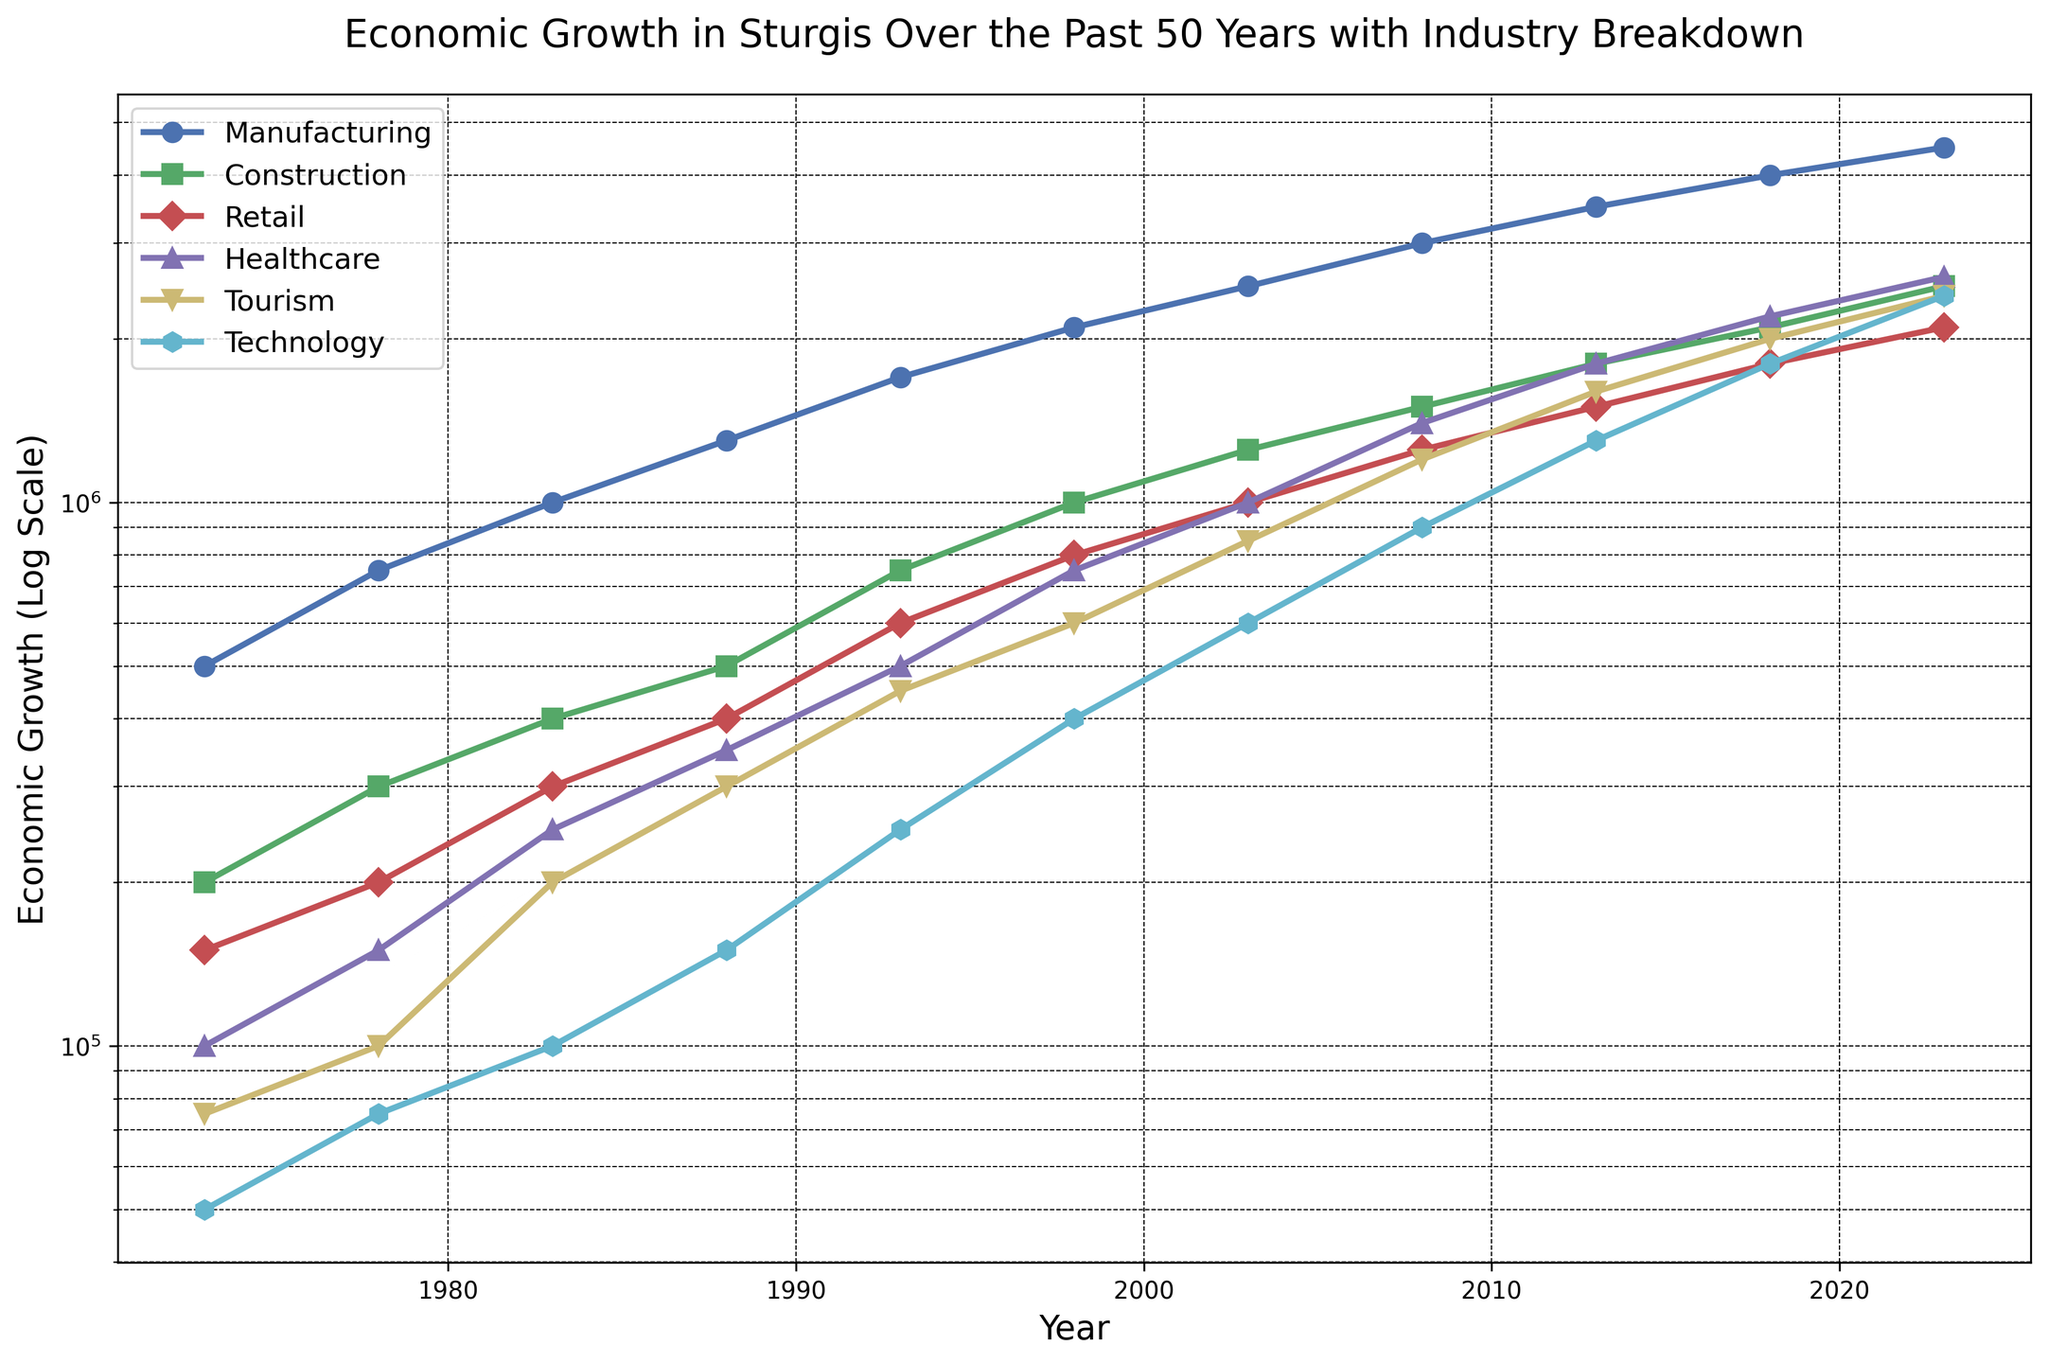Which industry experienced the highest economic growth in 1973? Look at the values for each industry in 1973. Manufacturing has the highest value at $500,000.
Answer: Manufacturing In 2023, how much higher is the economic growth in Healthcare compared to Retail? In 2023, the economic growth for Healthcare is $2,600,000 and for Retail it is $2,100,000. The difference is $2,600,000 - $2,100,000 = $500,000.
Answer: $500,000 By how much did the Technology sector grow between 2003 and 2023? In 2003, Technology had an economic growth of $600,000 and in 2023 it had $2,400,000. The growth is $2,400,000 - $600,000 = $1,800,000.
Answer: $1,800,000 Which two industries had the same economic growth in any given year? In 2013, Healthcare and Tourism both had an economic growth of $1,800,000. This is visible by comparing the values of these two industries for the year 2013.
Answer: Healthcare and Tourism in 2013 What was the average economic growth for the Construction industry over the 50 years? To calculate the average, sum the Construction data values from 1973 to 2023: $200,000 + $300,000 + $400,000 + $500,000 + $750,000 + $1,000,000 + $1,250,000 + $1,500,000 + $1,800,000 + $2,100,000 + $2,500,000 = $12,300,000. Then divide by the number of values (11): $12,300,000 / 11 ≈ $1,118,182.
Answer: $1,118,182 Between 1988 and 1998, which industry saw the largest relative increase in economic growth? Calculate the relative increase for each industry from 1988 to 1998: Manufacturing: ($2,100,000 - $1,300,000) / $1,300,000 = 0.6154; Construction: ($1,000,000 - $500,000) / $500,000 = 1.0; Retail: ($800,000 - $400,000) / $400,000 = 1.0; Healthcare: ($750,000 - $350,000) / $350,000 = 1.1429; Tourism: ($600,000 - $300,000) / $300,000 = 1.0; Technology: ($400,000 - $150,000) / $150,000 ≈ 1.6667. Technology has the largest relative increase.
Answer: Technology What is the trend in Tourism's economic growth from 1973 to 2023? Visually, Tourism's economic growth has been increasing steadily. Starting from $75,000 in 1973, it goes up every 5 years, reaching $2,400,000 in 2023.
Answer: Increasing steadily Which year exhibits the first instance where Technology's economic growth surpasses Retail's? Looking year by year, the first instance where Technology's economic growth surpasses Retail's is 2023. Technology has $2,400,000 while Retail has $2,100,000.
Answer: 2023 